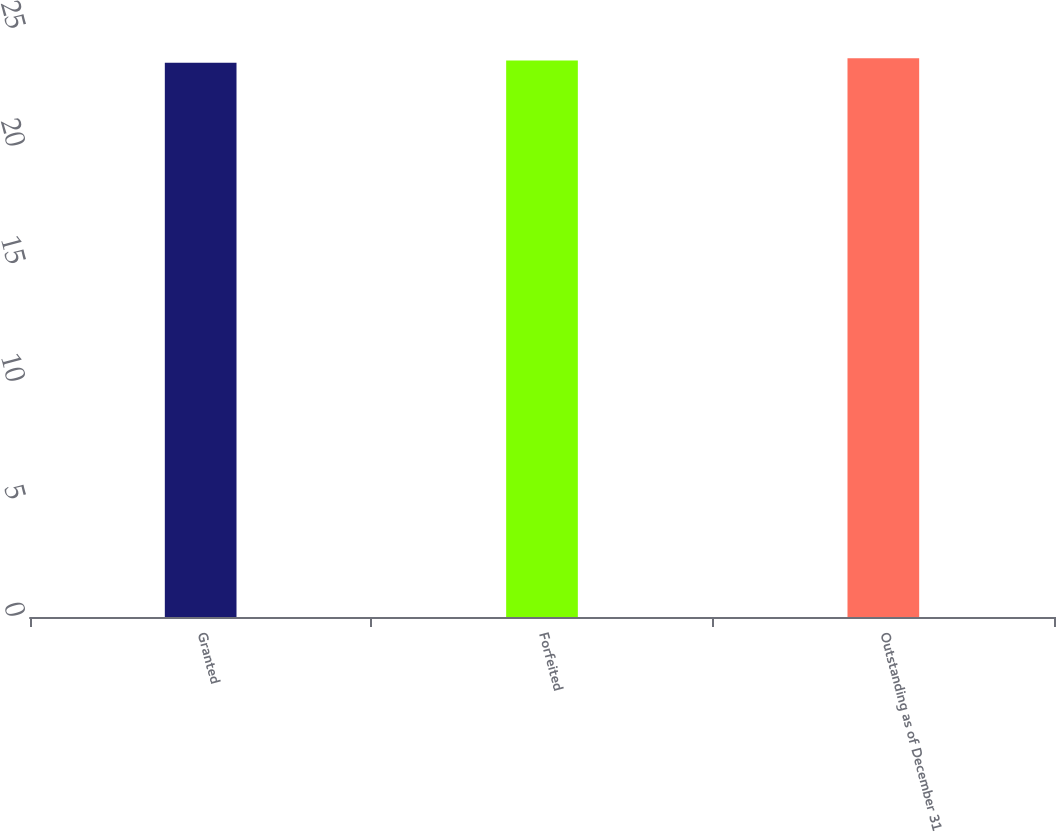Convert chart. <chart><loc_0><loc_0><loc_500><loc_500><bar_chart><fcel>Granted<fcel>Forfeited<fcel>Outstanding as of December 31<nl><fcel>23.56<fcel>23.66<fcel>23.76<nl></chart> 